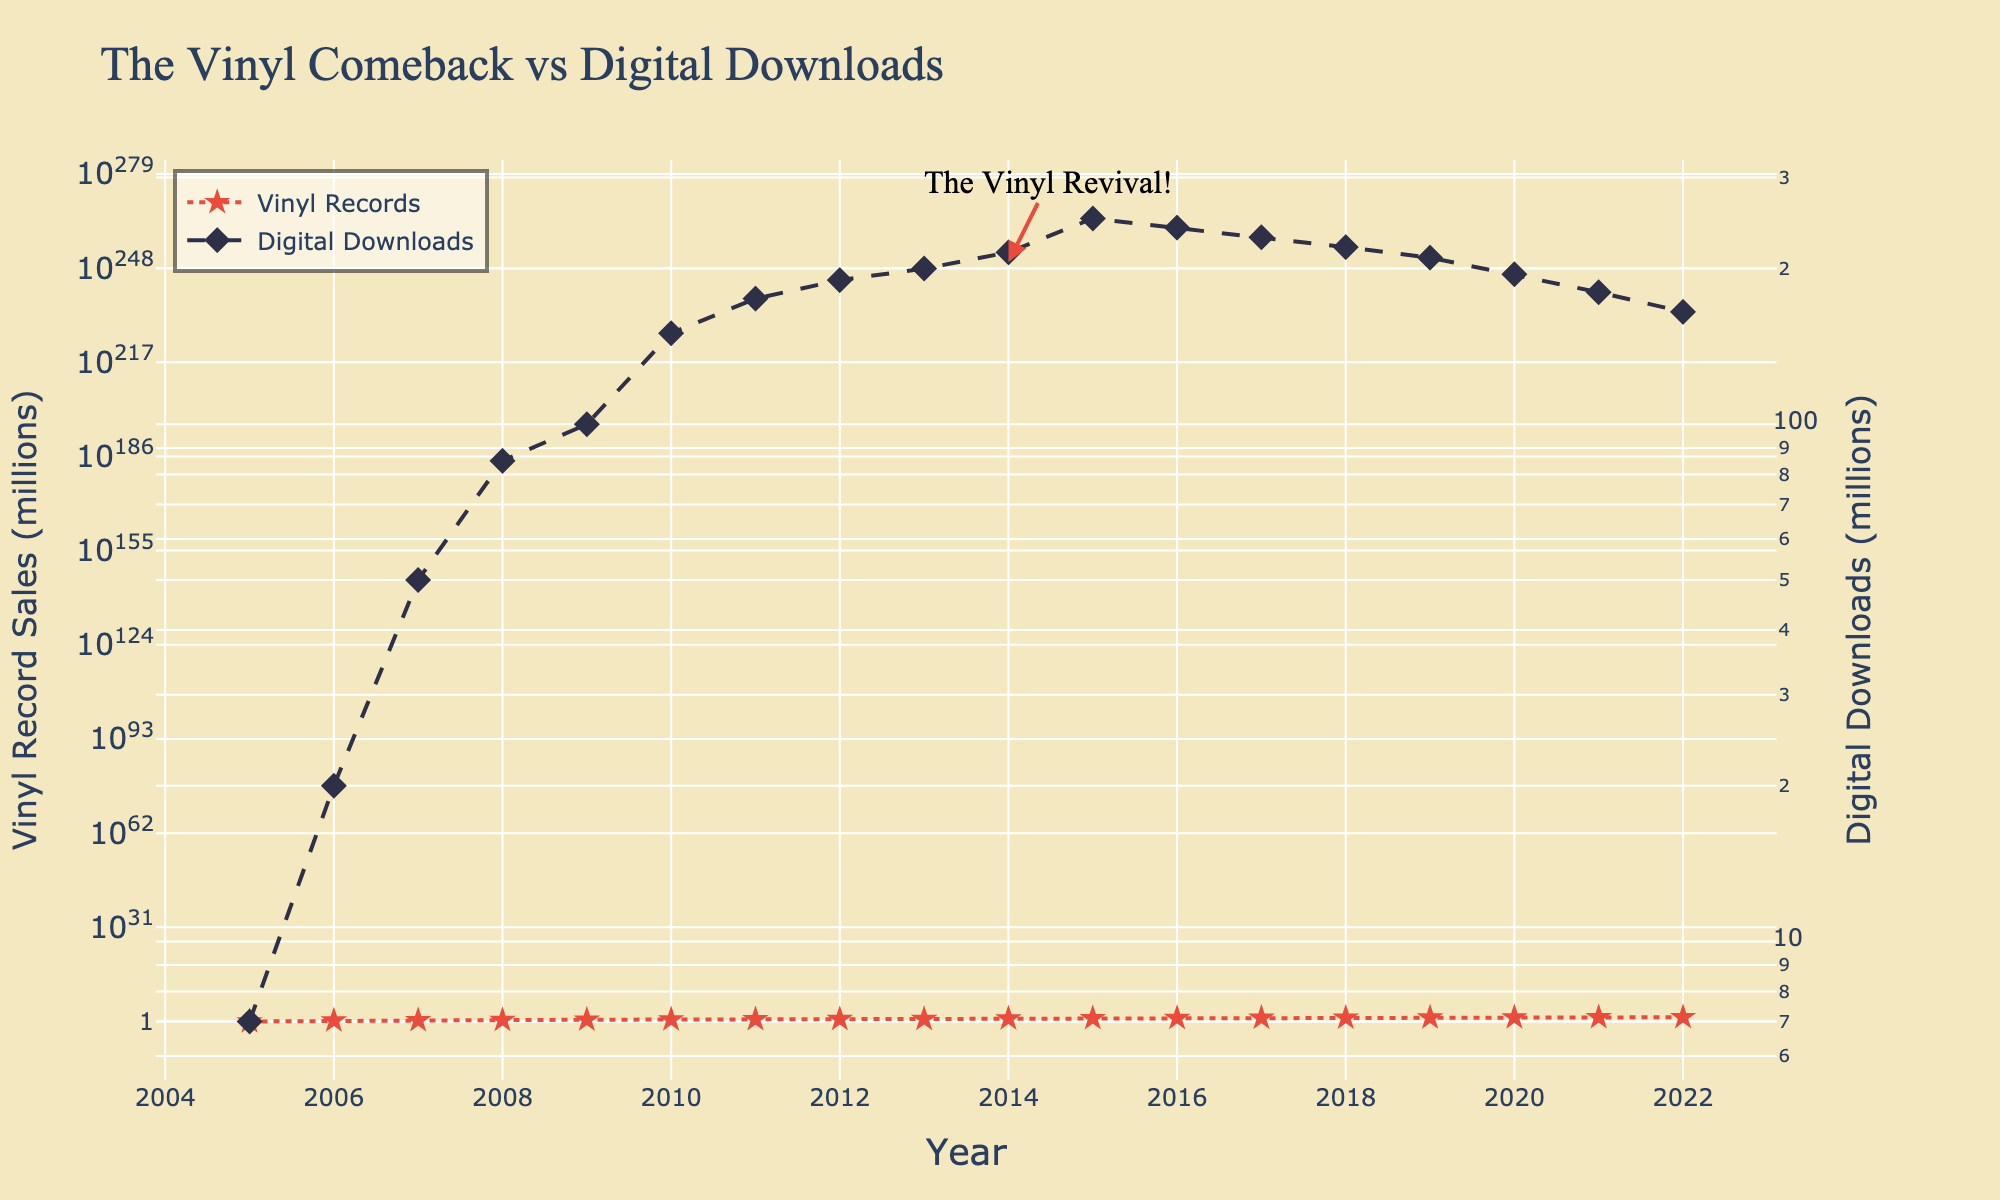When did vinyl record sales begin to show a noticeable increase? Vinyl record sales begin to show a noticeable increase starting from 2010, as indicated by the upward trend in the data points and the annotation highlighting the "Vinyl Revival" around 2014.
Answer: 2010 What is the title of the plot? The plot's title is clearly stated at the top of the figure.
Answer: The Vinyl Comeback vs Digital Downloads Which year had the highest vinyl record sales? To find the year with the highest vinyl record sales, locate the point on the vinyl records trend line with the highest y-value on the left Y-axis.
Answer: 2022 In 2020, what were the sales figures for vinyl records and digital downloads? Locate the data points on the graph corresponding to the year 2020 on the x-axis; match these points to their respective y-axis values.
Answer: Vinyl: 21.5 million, Digital: 195 million How did digital download sales trend from 2005 to 2022? Observe the trend line for digital downloads; it starts high, peaks around 2012-2015, and then gradually declines.
Answer: Increased then decreased Which form of media, digital downloads or vinyl records, saw a decrease in sales after a peak? Compare the trends of both digital downloads and vinyl records; digital downloads peak around 2015 and then decline, while vinyl records continue to rise.
Answer: Digital downloads What is the annotation on the plot, and when does it occur? The annotation "The Vinyl Revival!" is near the point for 2014, as shown clearly in the figure.
Answer: The Vinyl Revival, 2014 Compare the sales of vinyl records between 2010 and 2014. Identify and compare the y-values of vinyl record sales for 2010 and 2014; sales rise from approximately 4.5 million to 9.2 million.
Answer: From 4.5 million to 9.2 million What is the color and symbol used for the vinyl record sales in the plot? Notice the visual attributes of the vinyl record line in the plot: the color is red, and the symbol is a star.
Answer: Red and star Between which consecutive years did vinyl records sales experience the greatest growth? To find the largest increment, look for consecutive points on the vinyl records trend line with the greatest vertical distance; the biggest jump seems to occur between 2014 and 2015.
Answer: Between 2014 and 2015 